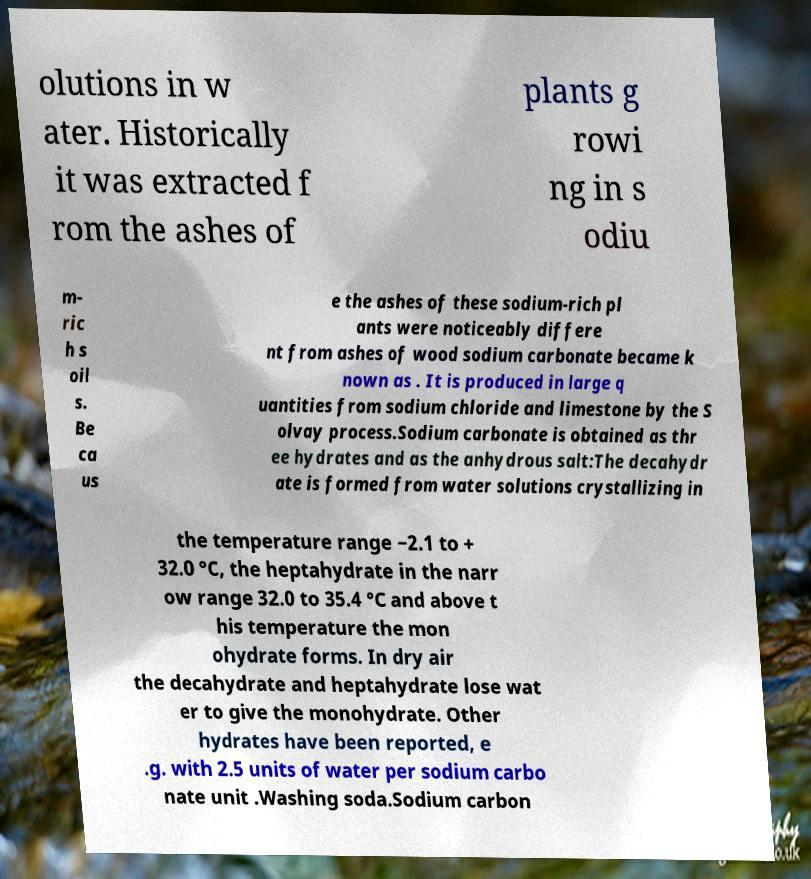Could you assist in decoding the text presented in this image and type it out clearly? olutions in w ater. Historically it was extracted f rom the ashes of plants g rowi ng in s odiu m- ric h s oil s. Be ca us e the ashes of these sodium-rich pl ants were noticeably differe nt from ashes of wood sodium carbonate became k nown as . It is produced in large q uantities from sodium chloride and limestone by the S olvay process.Sodium carbonate is obtained as thr ee hydrates and as the anhydrous salt:The decahydr ate is formed from water solutions crystallizing in the temperature range −2.1 to + 32.0 °C, the heptahydrate in the narr ow range 32.0 to 35.4 °C and above t his temperature the mon ohydrate forms. In dry air the decahydrate and heptahydrate lose wat er to give the monohydrate. Other hydrates have been reported, e .g. with 2.5 units of water per sodium carbo nate unit .Washing soda.Sodium carbon 